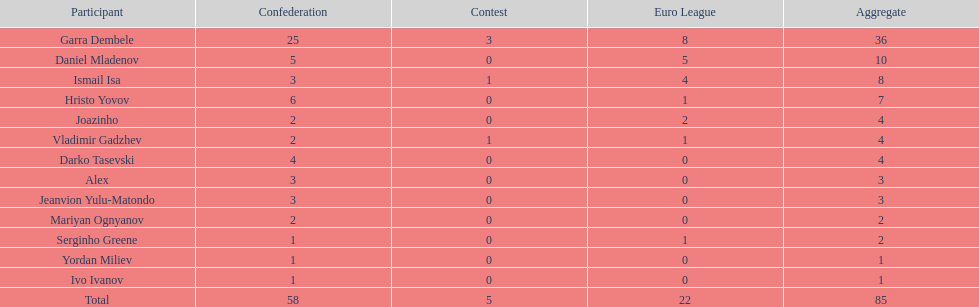Can you parse all the data within this table? {'header': ['Participant', 'Confederation', 'Contest', 'Euro League', 'Aggregate'], 'rows': [['Garra Dembele', '25', '3', '8', '36'], ['Daniel Mladenov', '5', '0', '5', '10'], ['Ismail Isa', '3', '1', '4', '8'], ['Hristo Yovov', '6', '0', '1', '7'], ['Joazinho', '2', '0', '2', '4'], ['Vladimir Gadzhev', '2', '1', '1', '4'], ['Darko Tasevski', '4', '0', '0', '4'], ['Alex', '3', '0', '0', '3'], ['Jeanvion Yulu-Matondo', '3', '0', '0', '3'], ['Mariyan Ognyanov', '2', '0', '0', '2'], ['Serginho Greene', '1', '0', '1', '2'], ['Yordan Miliev', '1', '0', '0', '1'], ['Ivo Ivanov', '1', '0', '0', '1'], ['Total', '58', '5', '22', '85']]} Who was the top goalscorer on this team? Garra Dembele. 